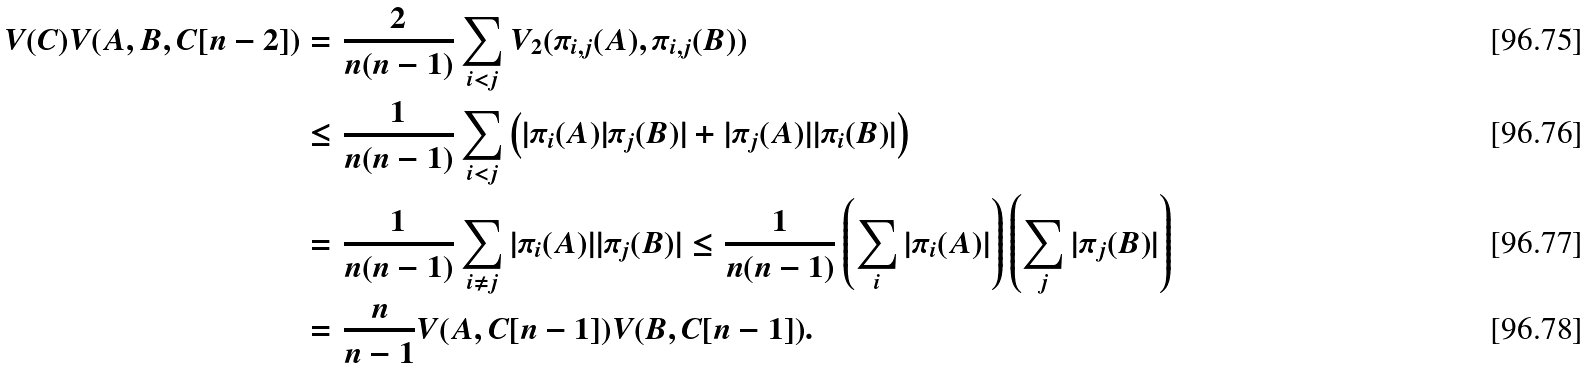Convert formula to latex. <formula><loc_0><loc_0><loc_500><loc_500>V ( C ) V ( A , B , C [ n - 2 ] ) & = \frac { 2 } { n ( n - 1 ) } \sum _ { i < j } V _ { 2 } ( \pi _ { i , j } ( A ) , \pi _ { i , j } ( B ) ) \\ & \leq \frac { 1 } { n ( n - 1 ) } \sum _ { i < j } \left ( | \pi _ { i } ( A ) | \pi _ { j } ( B ) | + | \pi _ { j } ( A ) | | \pi _ { i } ( B ) | \right ) \\ & = \frac { 1 } { n ( n - 1 ) } \sum _ { i \neq j } | \pi _ { i } ( A ) | | \pi _ { j } ( B ) | \leq \frac { 1 } { n ( n - 1 ) } \left ( \sum _ { i } | \pi _ { i } ( A ) | \right ) \left ( \sum _ { j } | \pi _ { j } ( B ) | \right ) \\ & = \frac { n } { n - 1 } V ( A , C [ n - 1 ] ) V ( B , C [ n - 1 ] ) .</formula> 